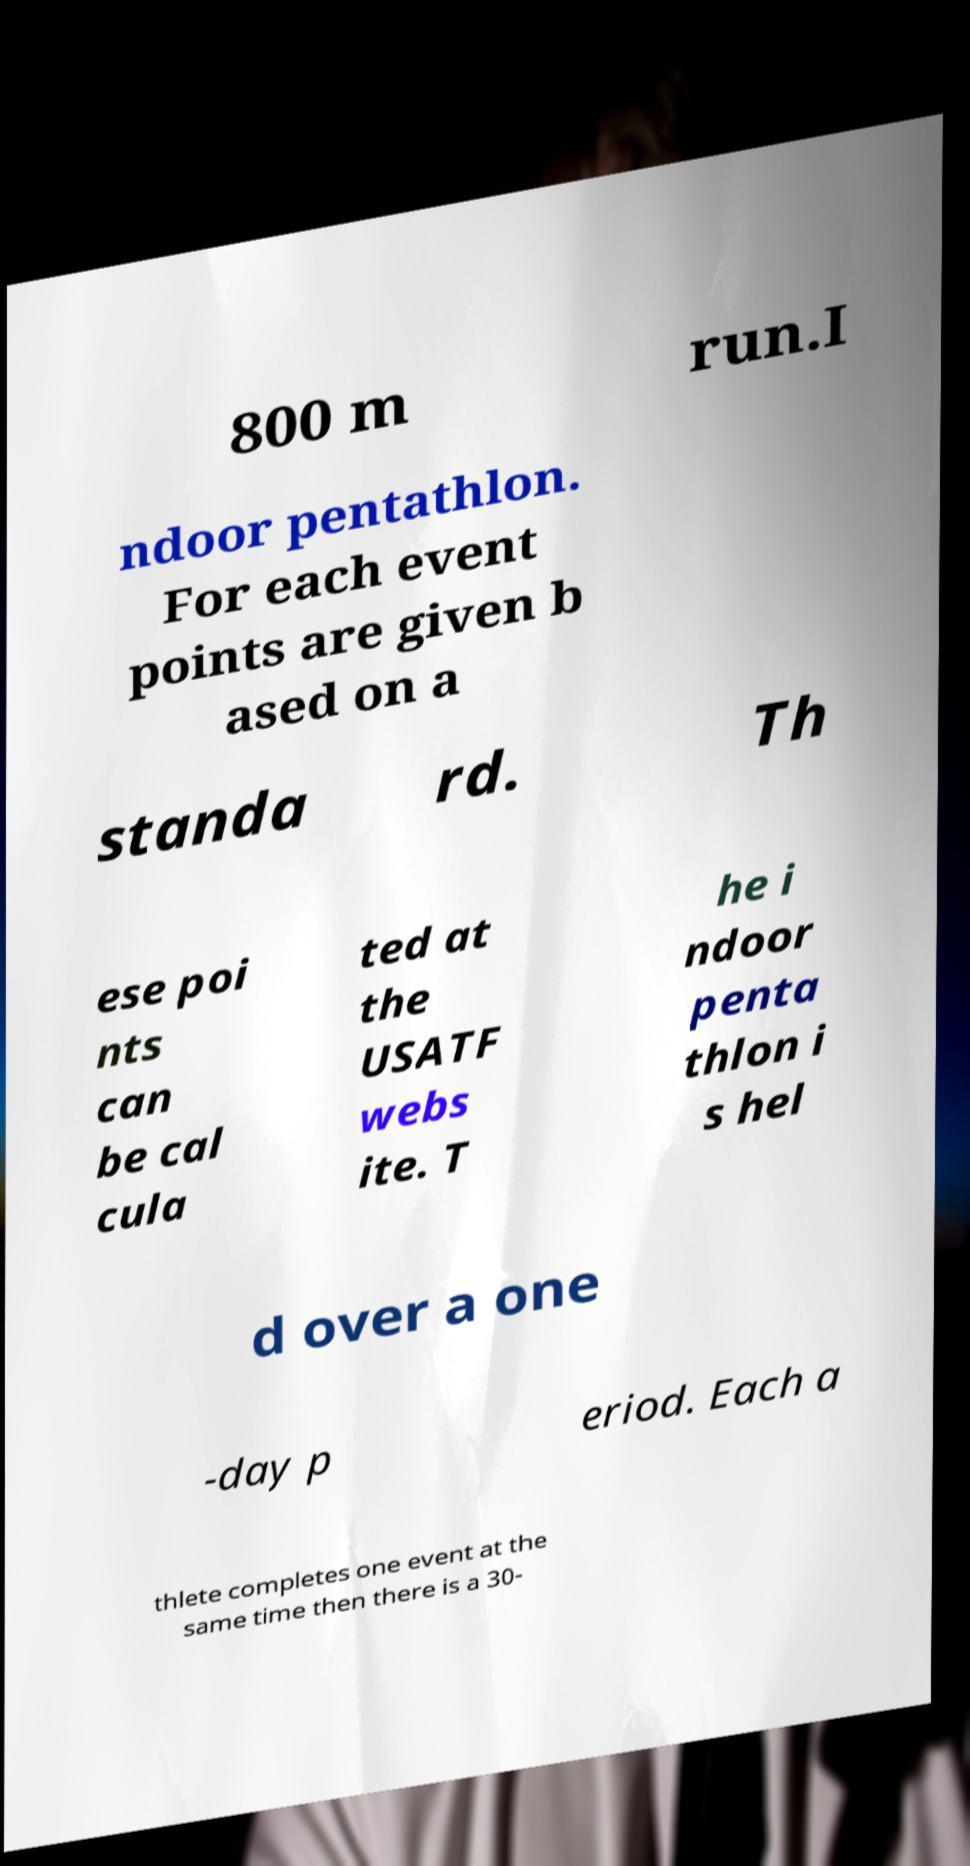Could you extract and type out the text from this image? 800 m run.I ndoor pentathlon. For each event points are given b ased on a standa rd. Th ese poi nts can be cal cula ted at the USATF webs ite. T he i ndoor penta thlon i s hel d over a one -day p eriod. Each a thlete completes one event at the same time then there is a 30- 